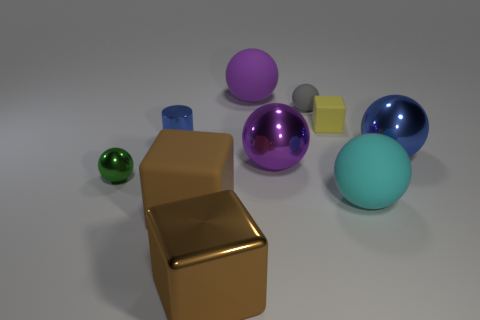Subtract all tiny gray rubber spheres. How many spheres are left? 5 Subtract all green balls. How many balls are left? 5 Subtract all blue balls. Subtract all red blocks. How many balls are left? 5 Subtract all spheres. How many objects are left? 4 Add 6 small cylinders. How many small cylinders exist? 7 Subtract 0 green cylinders. How many objects are left? 10 Subtract all green shiny cylinders. Subtract all yellow cubes. How many objects are left? 9 Add 2 metal objects. How many metal objects are left? 7 